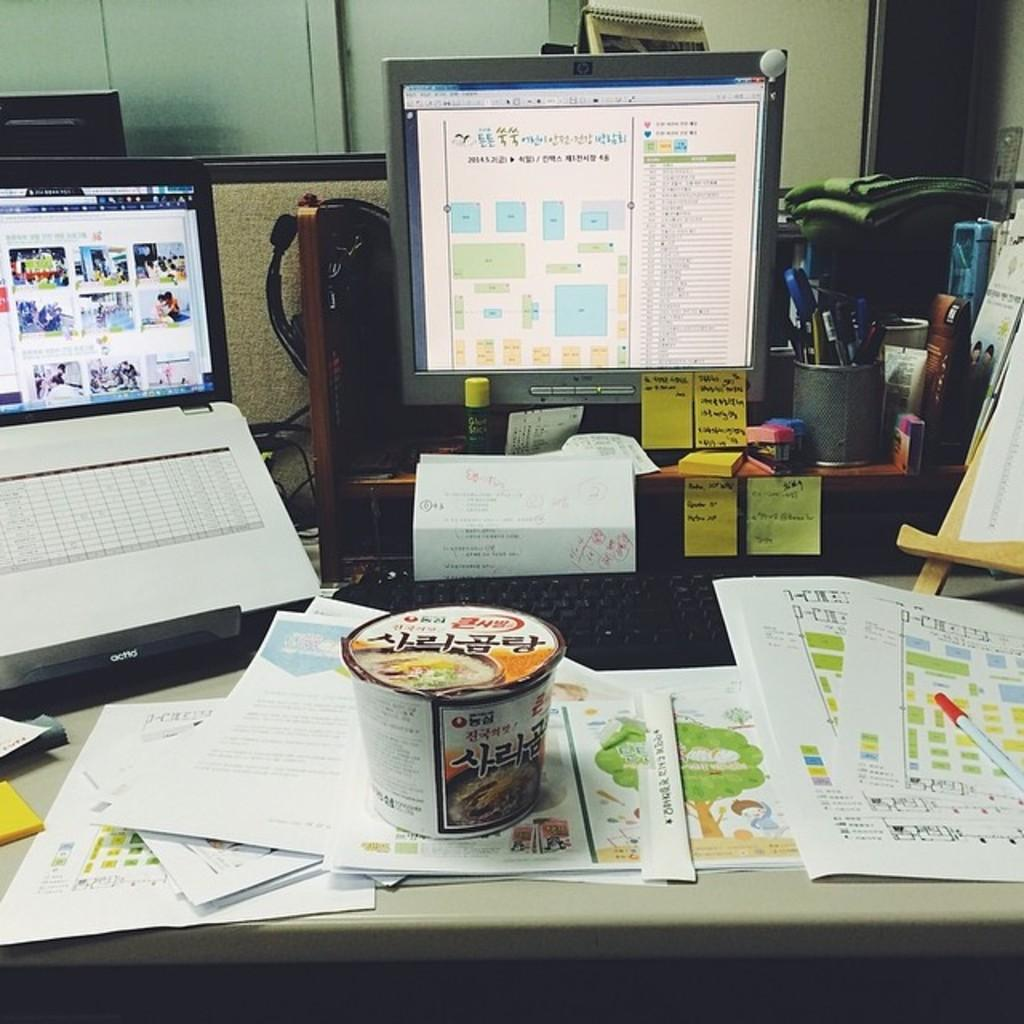What type of surface can be seen in the image? There is a wall in the image. What piece of furniture is present in the image? There is a table in the image. What is on the table? There is a cup of noodles, papers, a laptop, a screen, books, a box, pens, and a light on the table. What word can be heard being cried out in the image? There is no audible sound or word being cried out in the image. How does the screen turn when interacting with the laptop? The screen does not turn in the image; it is stationary on the table. 